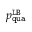<formula> <loc_0><loc_0><loc_500><loc_500>p _ { q u a } ^ { L B }</formula> 